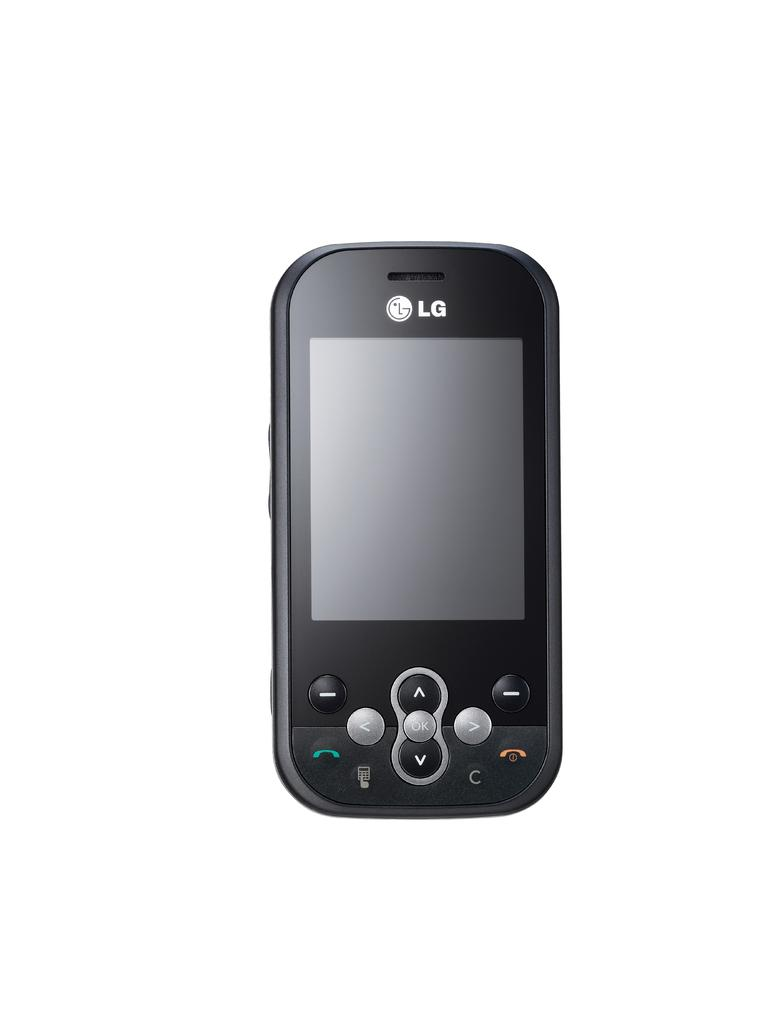<image>
Summarize the visual content of the image. A lg model following is looking towards a consumer the screen offers a small keyboard for up and down underneath it. 